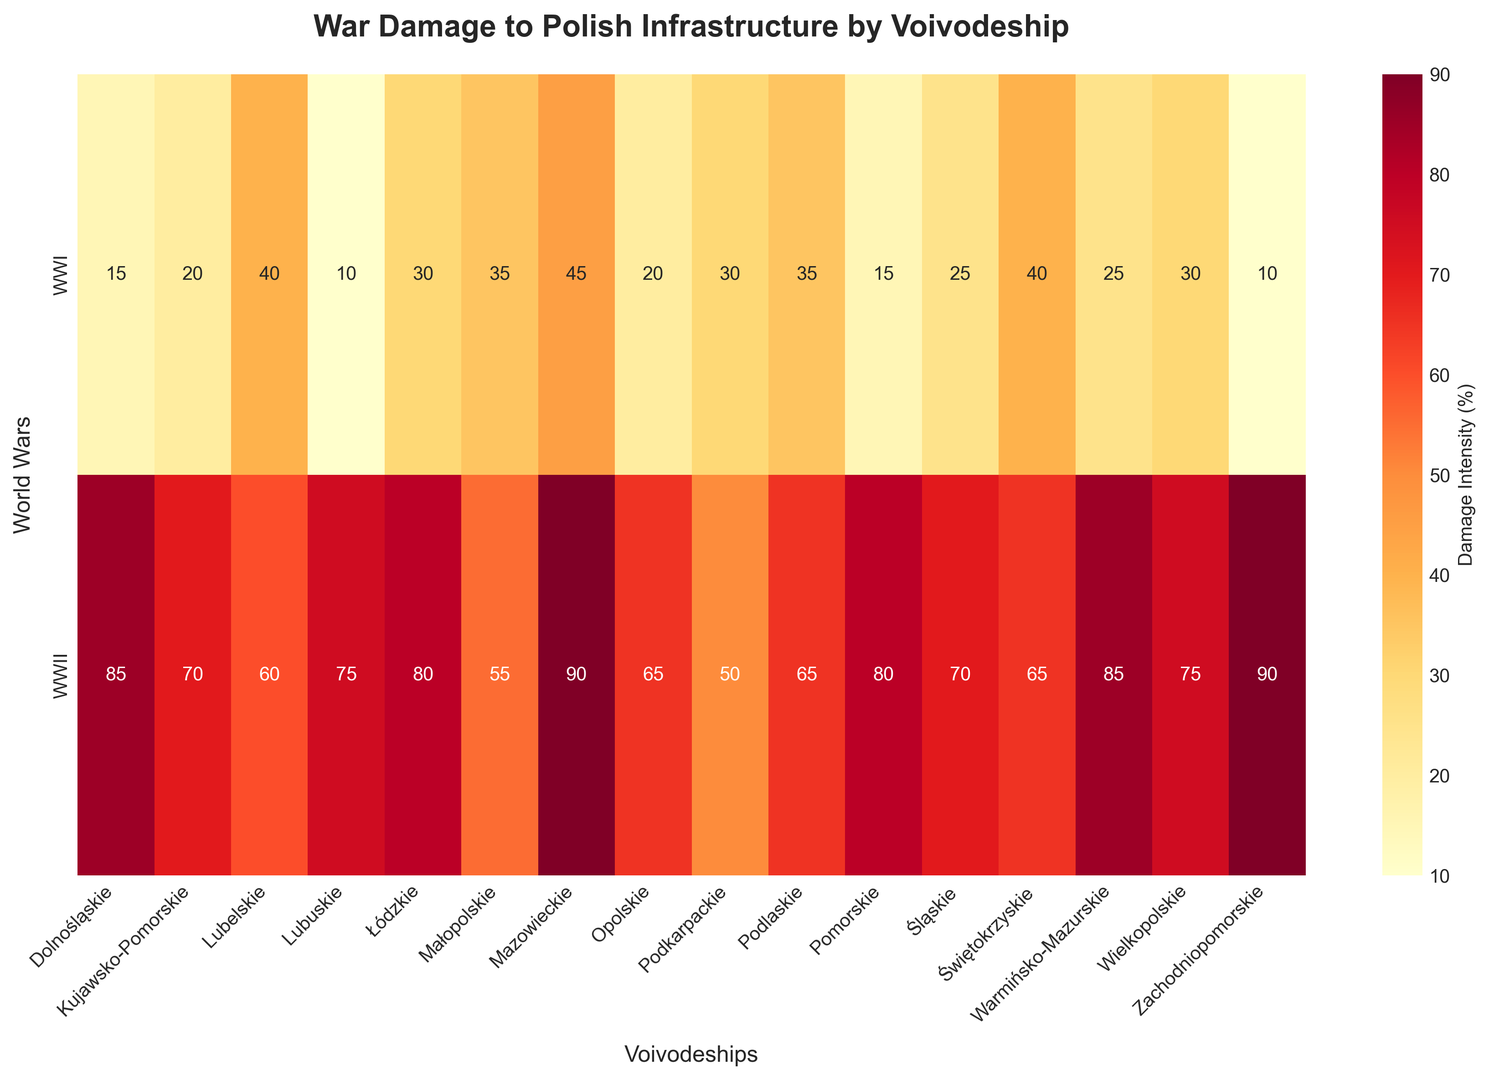Which voivodeship experienced the highest intensity of damage during WWII? Look for the voivodeship with the highest value in the WWII row. Mazowieckie has a value of 90, which is the highest.
Answer: Mazowieckie Which voivodeship had the least damage during WWI? Look for the voivodeship with the lowest value in the WWI row. Lubuskie and Zachodniopomorskie both have a value of 10, which is the lowest.
Answer: Lubuskie and Zachodniopomorskie What is the total war damage (WWI + WWII) for Łódzkie? Sum the values for Łódzkie in both rows. 30 (WWI) + 80 (WWII) = 110.
Answer: 110 Which voivodeship showed the greatest increase in damage intensity from WWI to WWII? Calculate the difference for each voivodeship between WWII and WWI. The greatest difference is 80 for Dolnośląskie (85 - 15).
Answer: Dolnośląskie How does the damage intensity in Świętokrzyskie during WWI compare to that during WWII? Compare the values for Świętokrzyskie in both rows. WWI has 40 and WWII has 65, indicating an increase.
Answer: Increased Which wars caused more damage to the Mazowieckie voivodeship, WWI or WWII? Compare the values for Mazowieckie in both rows. WWI has 45 and WWII has 90. WWII caused more damage.
Answer: WWII What’s the average damage intensity for all voivodeships during WWI? Add all the WWI values and divide by the number of voivodeships (16). (15+20+40+10+30+35+45+20+30+35+15+25+40+25+30+10)/16 = 27.5.
Answer: 27.5 Which voivodeship has the highest disparity in damage intensity between WWI and WWII? Find the voivodeship with the largest absolute difference between WWI and WWII values. Dolnośląskie has the largest difference of 70 (85 - 15).
Answer: Dolnośląskie Which voivodeship had the second highest damage intensity during WWII? Identify the second-highest value in the WWII row. Warmińsko-Mazurskie and Dolnośląskie both have a value of 85, which is the second highest.
Answer: Warmińsko-Mazurskie and Dolnośląskie What is the visual color range of the heatmap for damage intensity? Observe the heatmap color range. It transitions from yellow (low intensity) to red (high intensity).
Answer: Yellow to Red 